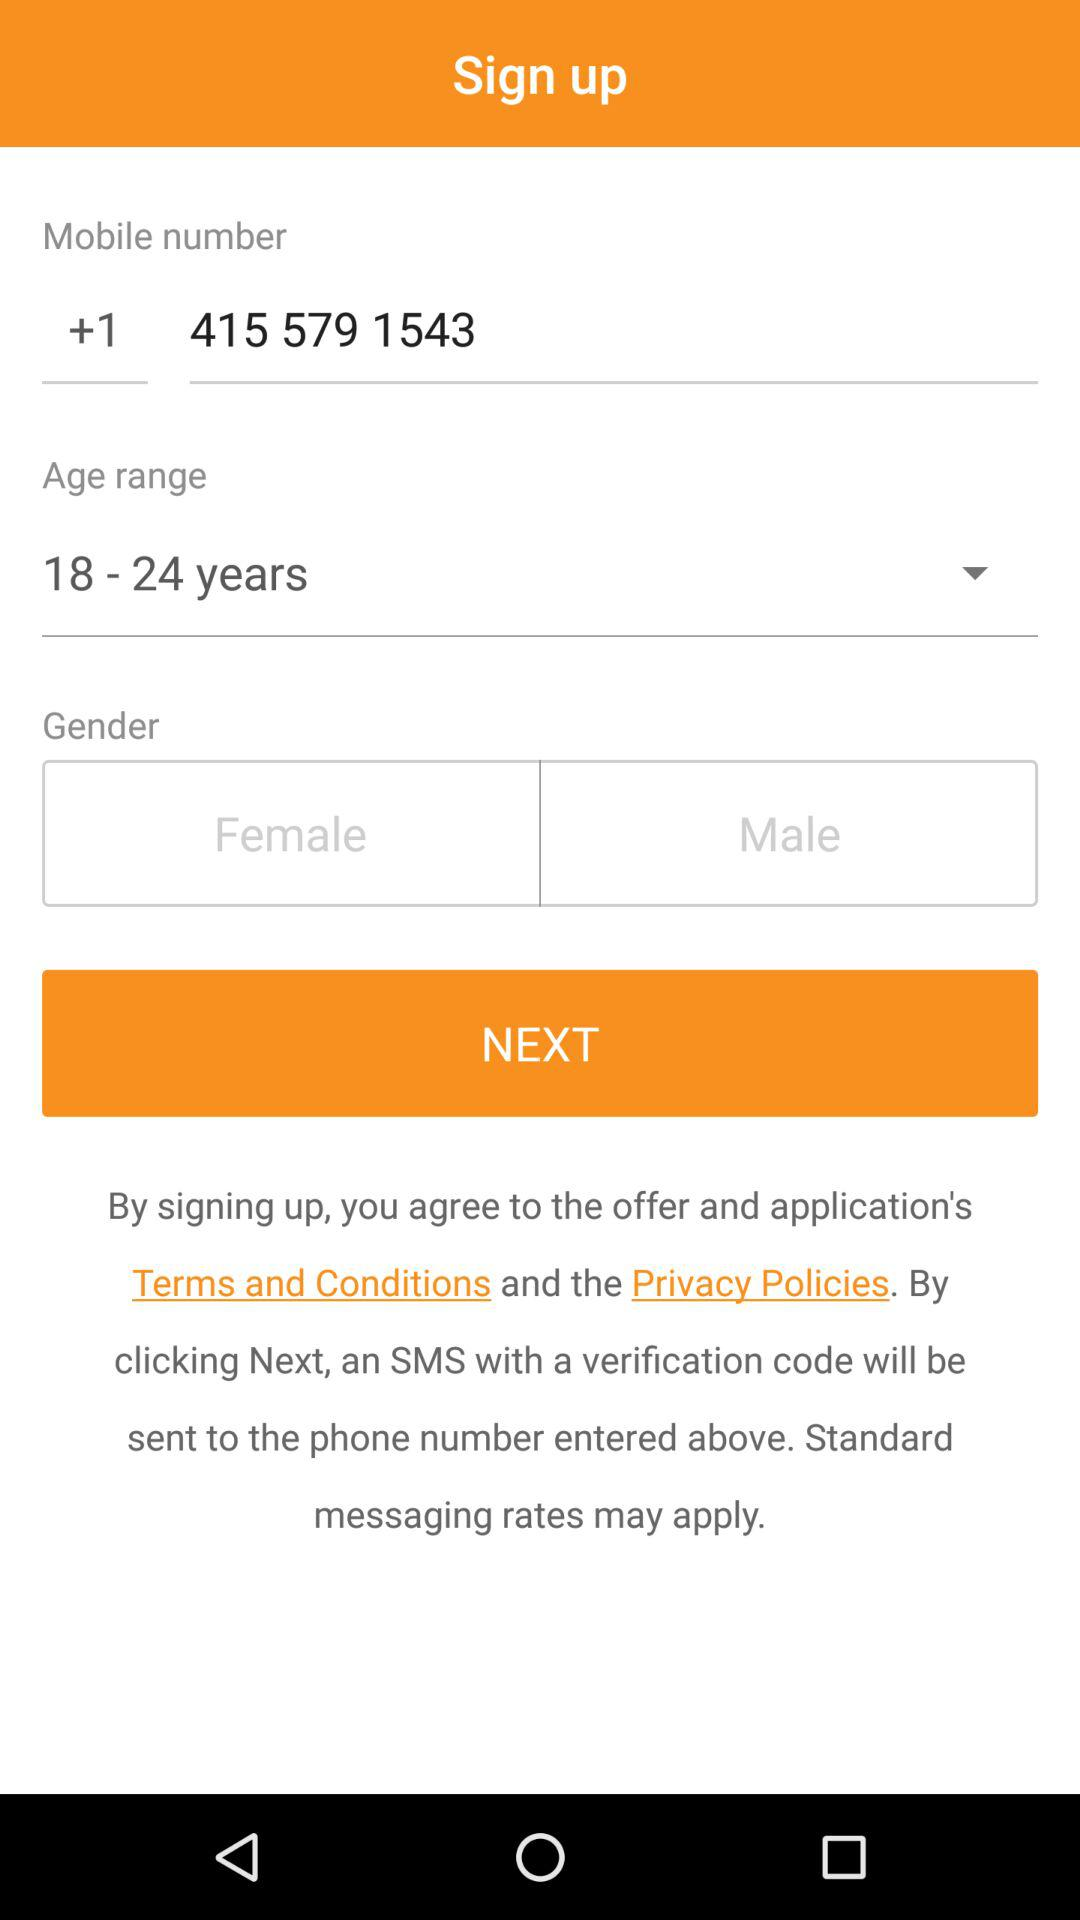What is the mobile number? The mobile number is +14155791543. 